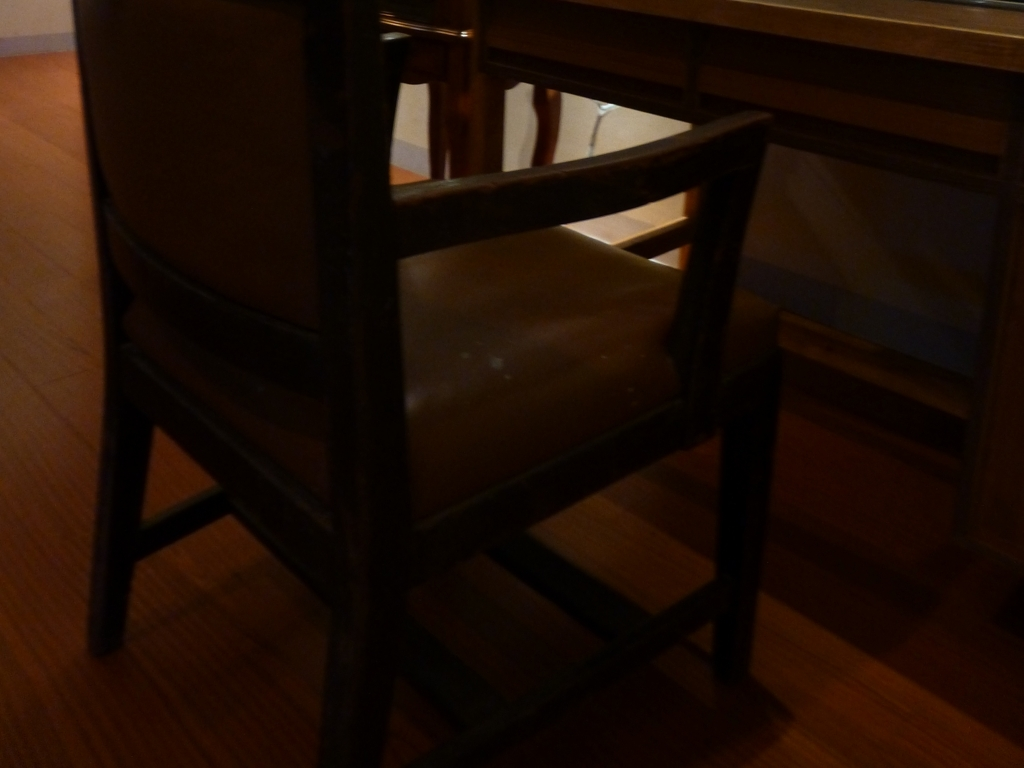What is the quality of the image?
A. Excellent
B. Poor
C. Average
D. Good The quality of the image seems to fall under option B, Poor, as it is quite underexposed which leads to the loss of detail and significant portions of the image being cloaked in shadows, making it challenging to discern finer details. 